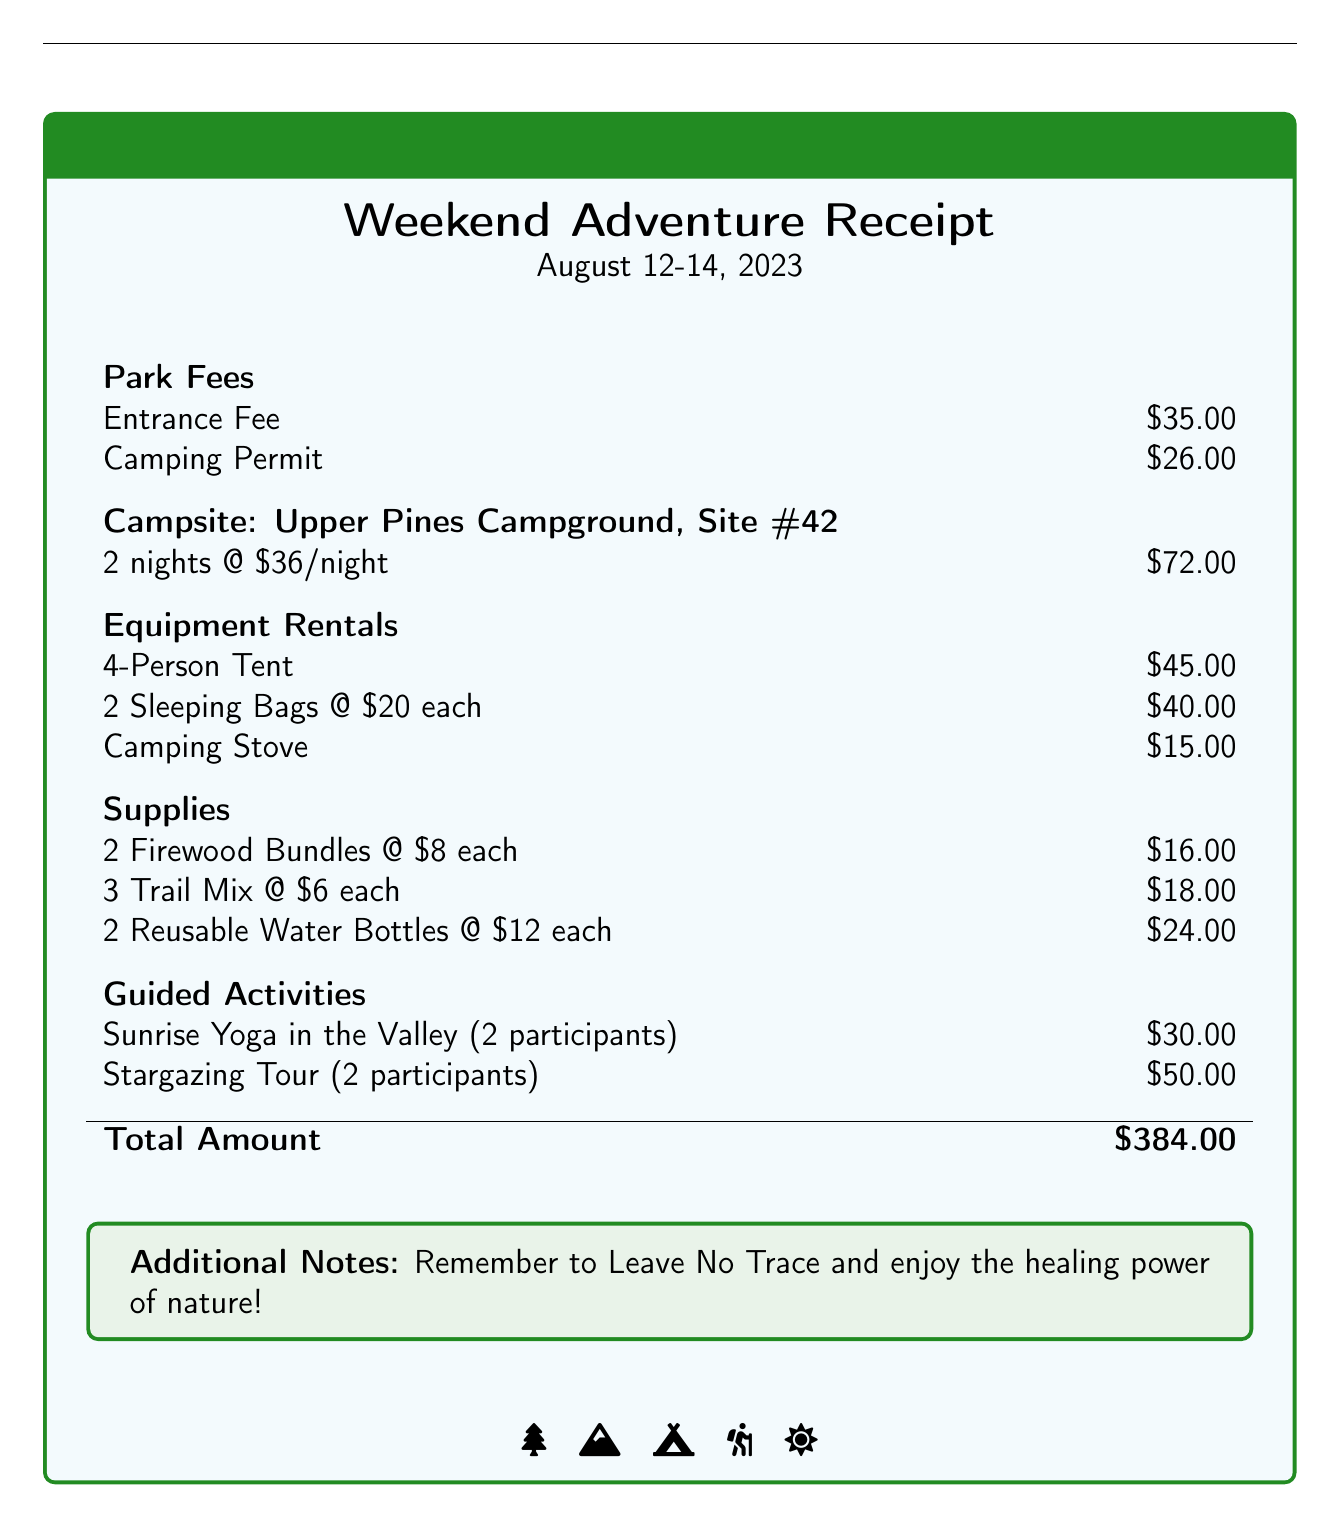What is the entrance fee? The entrance fee is listed in the section of park fees as \$35.00.
Answer: \$35.00 How much did the camping permit cost? The camping permit cost is stated in the park fees section and amounts to \$26.00.
Answer: \$26.00 What is the total amount for the trip? The total amount is calculated from all sections and is listed at the end as \$384.00.
Answer: \$384.00 How many nights was the campsite reserved? The campsite stayed for 2 nights, as indicated in the campsite details of the document.
Answer: 2 nights What was the cost of the 4-person tent rental? The document specifies the cost of renting a 4-person tent as \$45.00 in the equipment rentals section.
Answer: \$45.00 What was included in the guided activities? The document lists two activities: Sunrise Yoga in the Valley and Stargazing Tour, both with their costs.
Answer: Sunrise Yoga in the Valley, Stargazing Tour How many bundles of firewood were purchased? The supplies section of the document states that 2 bundles of firewood were bought.
Answer: 2 bundles What campsite was used for the trip? The section identifying the campsite specifies Upper Pines Campground, Site #42.
Answer: Upper Pines Campground, Site #42 What type of document is this? This document is a receipt detailing expenses for a camping trip.
Answer: Receipt 